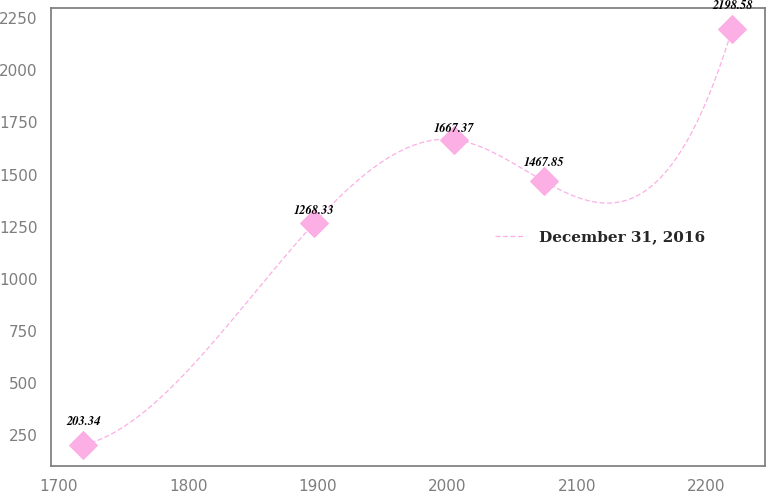<chart> <loc_0><loc_0><loc_500><loc_500><line_chart><ecel><fcel>December 31, 2016<nl><fcel>1719.19<fcel>203.34<nl><fcel>1897.47<fcel>1268.33<nl><fcel>2005.31<fcel>1667.37<nl><fcel>2074.58<fcel>1467.85<nl><fcel>2219.77<fcel>2198.58<nl></chart> 